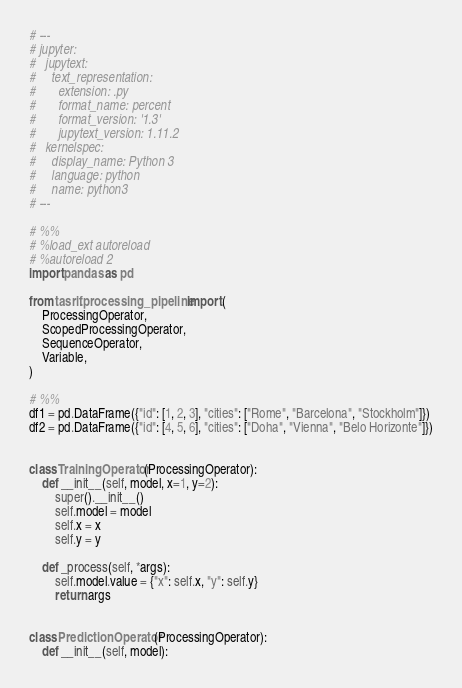Convert code to text. <code><loc_0><loc_0><loc_500><loc_500><_Python_># ---
# jupyter:
#   jupytext:
#     text_representation:
#       extension: .py
#       format_name: percent
#       format_version: '1.3'
#       jupytext_version: 1.11.2
#   kernelspec:
#     display_name: Python 3
#     language: python
#     name: python3
# ---

# %%
# %load_ext autoreload
# %autoreload 2
import pandas as pd

from tasrif.processing_pipeline import (
    ProcessingOperator,
    ScopedProcessingOperator,
    SequenceOperator,
    Variable,
)

# %%
df1 = pd.DataFrame({"id": [1, 2, 3], "cities": ["Rome", "Barcelona", "Stockholm"]})
df2 = pd.DataFrame({"id": [4, 5, 6], "cities": ["Doha", "Vienna", "Belo Horizonte"]})


class TrainingOperator(ProcessingOperator):
    def __init__(self, model, x=1, y=2):
        super().__init__()
        self.model = model
        self.x = x
        self.y = y

    def _process(self, *args):
        self.model.value = {"x": self.x, "y": self.y}
        return args


class PredictionOperator(ProcessingOperator):
    def __init__(self, model):</code> 